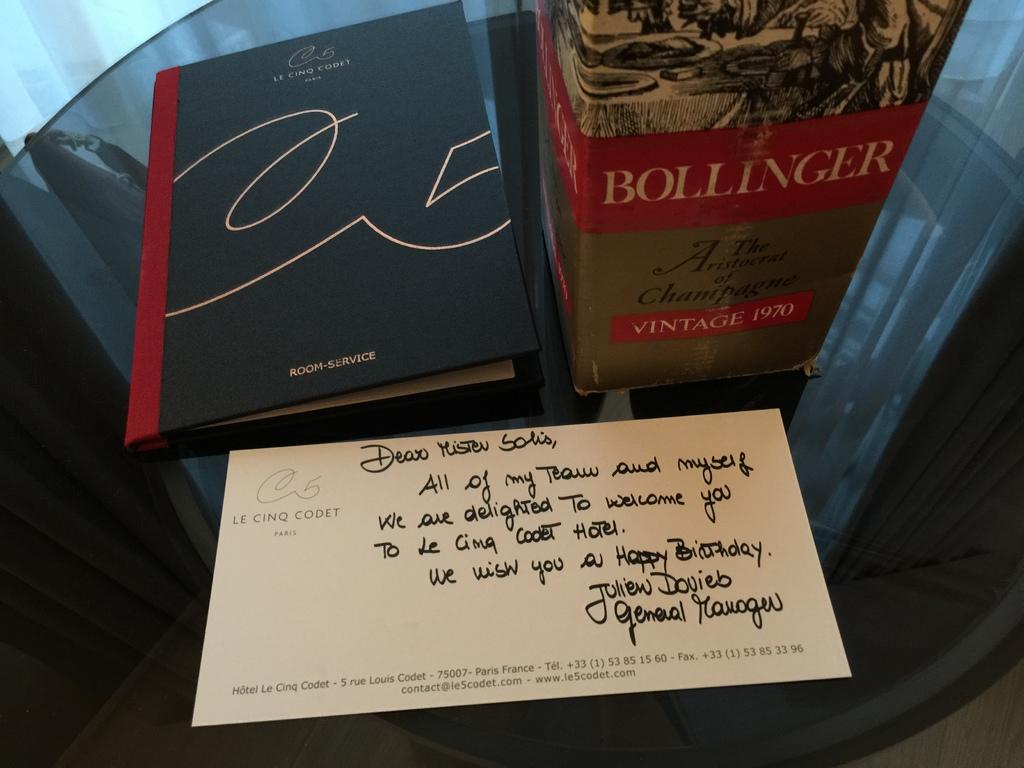What is the name of the book?
Give a very brief answer. Bollinger. 